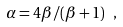<formula> <loc_0><loc_0><loc_500><loc_500>\alpha = 4 \beta / ( \beta + 1 ) \ ,</formula> 